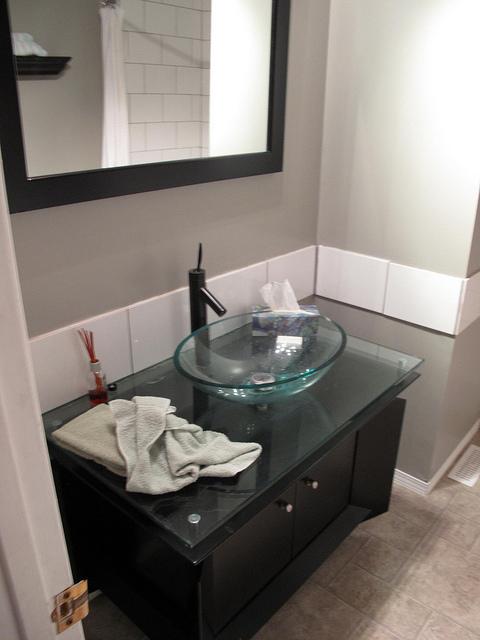Is the sink basin clear?
Give a very brief answer. Yes. Is there a reflection in the mirror?
Short answer required. Yes. Is this a bathroom?
Concise answer only. Yes. 